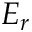<formula> <loc_0><loc_0><loc_500><loc_500>E _ { r }</formula> 